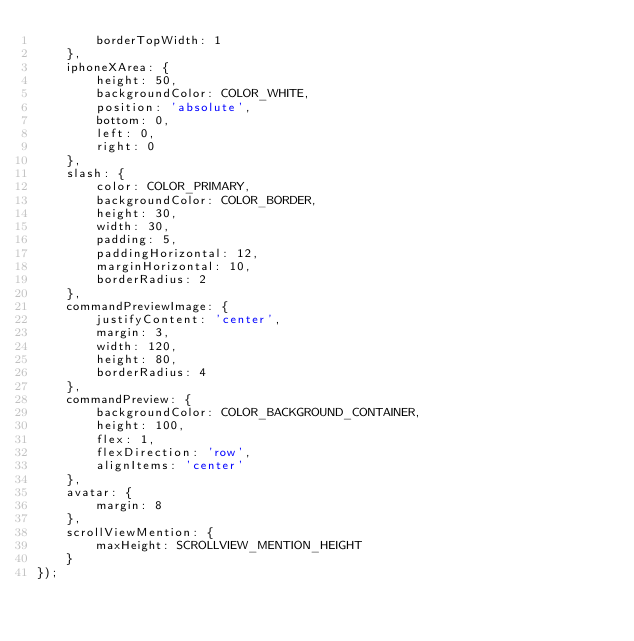<code> <loc_0><loc_0><loc_500><loc_500><_JavaScript_>		borderTopWidth: 1
	},
	iphoneXArea: {
		height: 50,
		backgroundColor: COLOR_WHITE,
		position: 'absolute',
		bottom: 0,
		left: 0,
		right: 0
	},
	slash: {
		color: COLOR_PRIMARY,
		backgroundColor: COLOR_BORDER,
		height: 30,
		width: 30,
		padding: 5,
		paddingHorizontal: 12,
		marginHorizontal: 10,
		borderRadius: 2
	},
	commandPreviewImage: {
		justifyContent: 'center',
		margin: 3,
		width: 120,
		height: 80,
		borderRadius: 4
	},
	commandPreview: {
		backgroundColor: COLOR_BACKGROUND_CONTAINER,
		height: 100,
		flex: 1,
		flexDirection: 'row',
		alignItems: 'center'
	},
	avatar: {
		margin: 8
	},
	scrollViewMention: {
		maxHeight: SCROLLVIEW_MENTION_HEIGHT
	}
});
</code> 